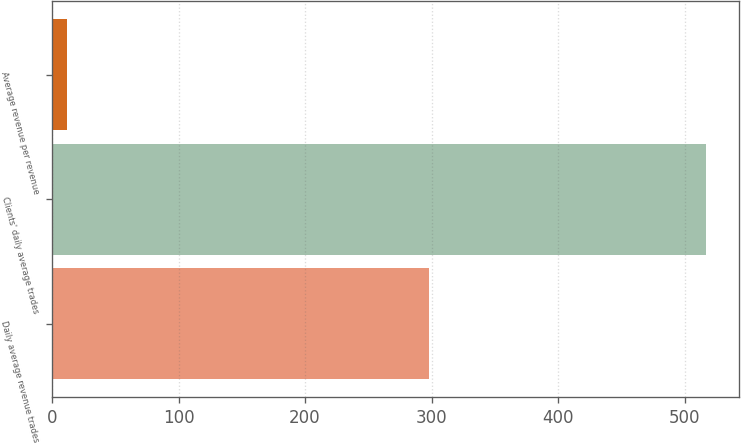<chart> <loc_0><loc_0><loc_500><loc_500><bar_chart><fcel>Daily average revenue trades<fcel>Clients' daily average trades<fcel>Average revenue per revenue<nl><fcel>298.2<fcel>516.8<fcel>12.13<nl></chart> 